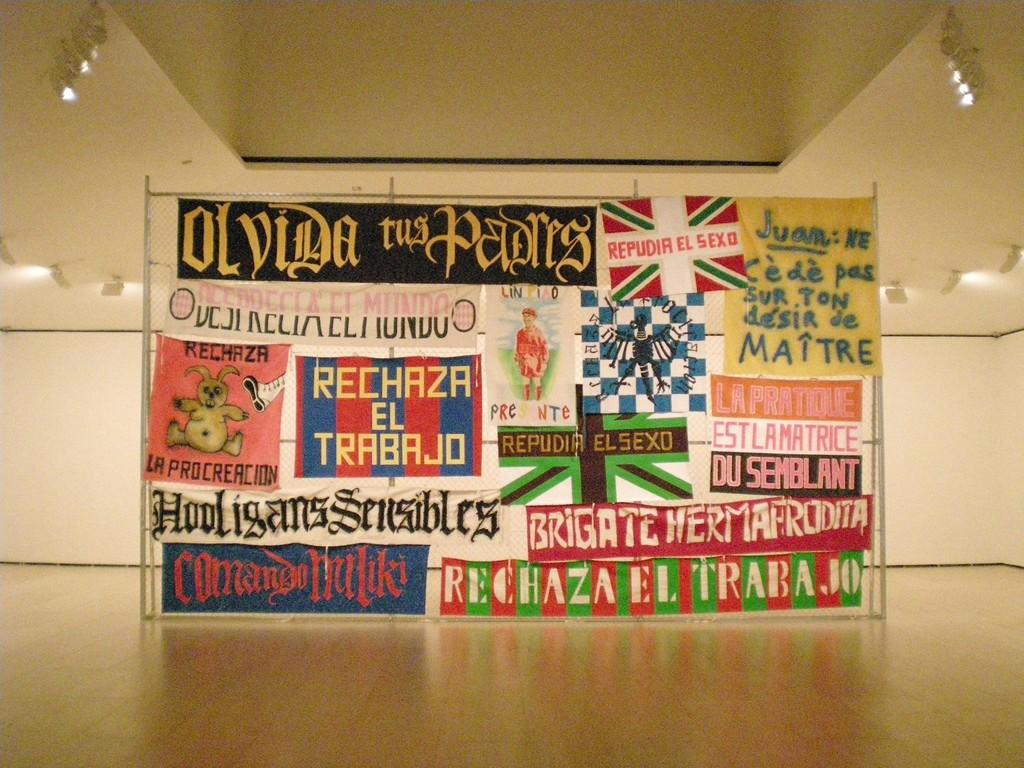What is the color of the hall in the image? The hall in the image is cream in color. What decorations can be seen on the walls? There are banners and flag paintings on the walls. Where are the lights located in the image? The lights are on the ceiling on either side. What type of root can be seen growing on the walls in the image? There are no roots visible on the walls in the image; it features a cream-colored hall with banners and flag paintings. 